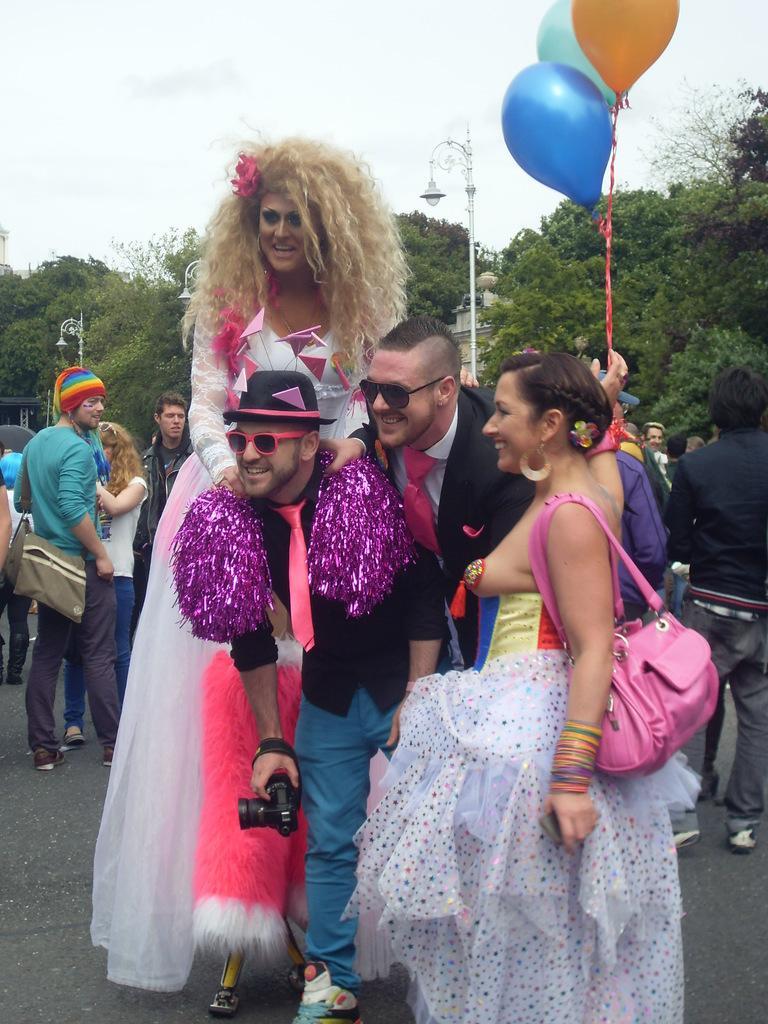Could you give a brief overview of what you see in this image? In this image I can see number of people are standing and I can see few of them are wearing costumes. In the front I can see one man is holding a camera. In the background I can see number of trees, three balloons, few poles, few lights and the sky. 